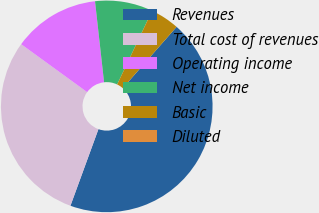Convert chart to OTSL. <chart><loc_0><loc_0><loc_500><loc_500><pie_chart><fcel>Revenues<fcel>Total cost of revenues<fcel>Operating income<fcel>Net income<fcel>Basic<fcel>Diluted<nl><fcel>44.11%<fcel>29.42%<fcel>13.23%<fcel>8.82%<fcel>4.41%<fcel>0.0%<nl></chart> 